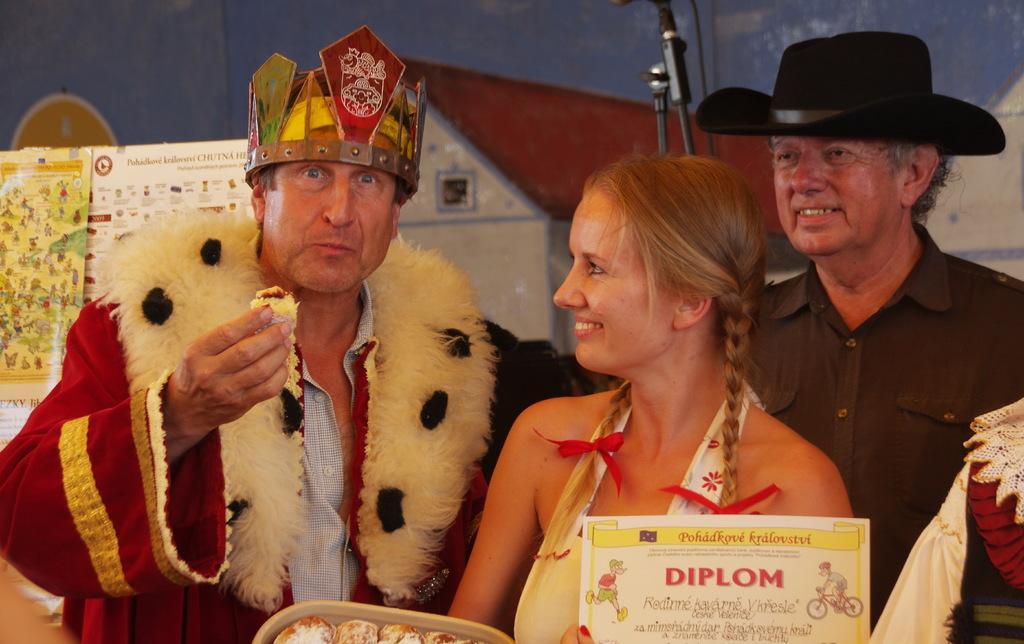Could you give a brief overview of what you see in this image? Here I can see three people. The man who is standing on the left side is wearing a red color jacket, cap on the head and eating some food item by holding in the hand. Beside this man there is a woman is holding a box which consists of some food items in it and also a paper. She is smiling by looking at this man. At the back of her I can see another man is wearing a black color shirt, cap on the head and smiling. In the background, I can see a wall to which some posters are attached and also there is a stand. 